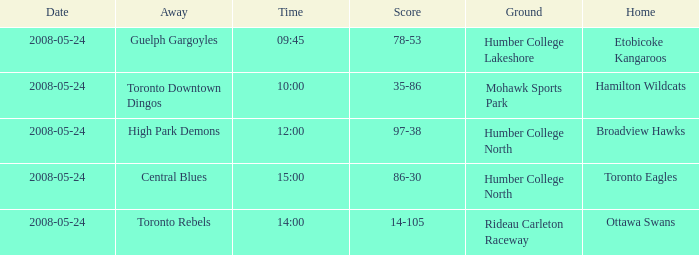Can you give me this table as a dict? {'header': ['Date', 'Away', 'Time', 'Score', 'Ground', 'Home'], 'rows': [['2008-05-24', 'Guelph Gargoyles', '09:45', '78-53', 'Humber College Lakeshore', 'Etobicoke Kangaroos'], ['2008-05-24', 'Toronto Downtown Dingos', '10:00', '35-86', 'Mohawk Sports Park', 'Hamilton Wildcats'], ['2008-05-24', 'High Park Demons', '12:00', '97-38', 'Humber College North', 'Broadview Hawks'], ['2008-05-24', 'Central Blues', '15:00', '86-30', 'Humber College North', 'Toronto Eagles'], ['2008-05-24', 'Toronto Rebels', '14:00', '14-105', 'Rideau Carleton Raceway', 'Ottawa Swans']]} Who was the away team of the game at the time 15:00? Central Blues. 